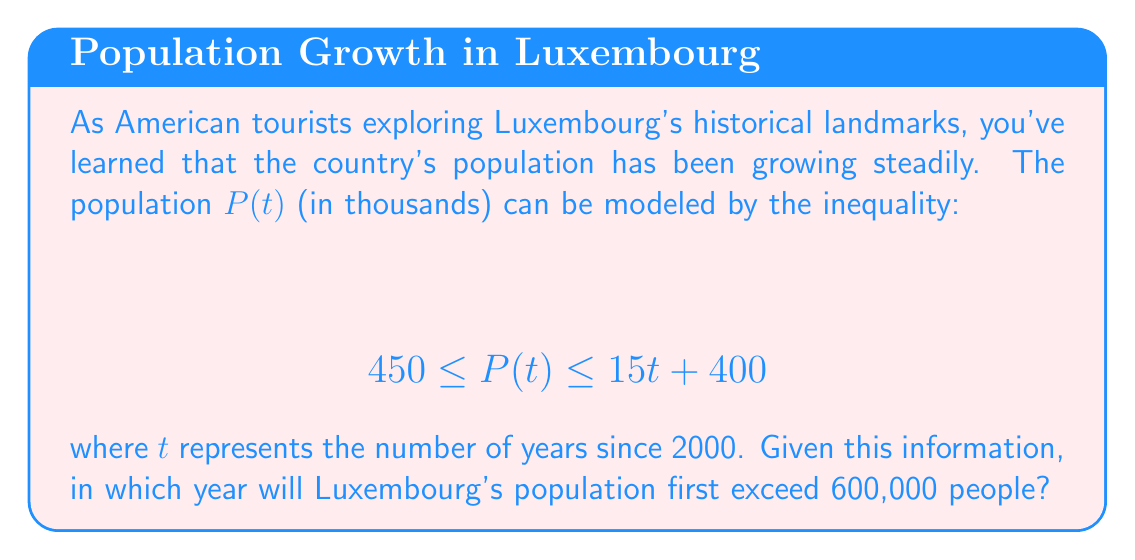Can you answer this question? To solve this problem, we need to follow these steps:

1) We're looking for the year when the population exceeds 600,000. In our inequality, P(t) is in thousands, so we need to solve for when the upper bound equals 600:

   $$ 15t + 400 = 600 $$

2) Subtract 400 from both sides:

   $$ 15t = 200 $$

3) Divide both sides by 15:

   $$ t = \frac{200}{15} \approx 13.33 $$

4) Since t represents the number of years since 2000, we need to add this to 2000:

   $$ 2000 + 13.33 \approx 2013.33 $$

5) However, we're asked for the first year the population exceeds 600,000. Since we can't have a fractional year, we need to round up to the next whole year.

6) Therefore, 2014 is the first year the population could exceed 600,000.

7) To verify, we can check the inequality for t = 14:

   $$ 15(14) + 400 = 610 $$

   Indeed, 610,000 exceeds 600,000.
Answer: 2014 